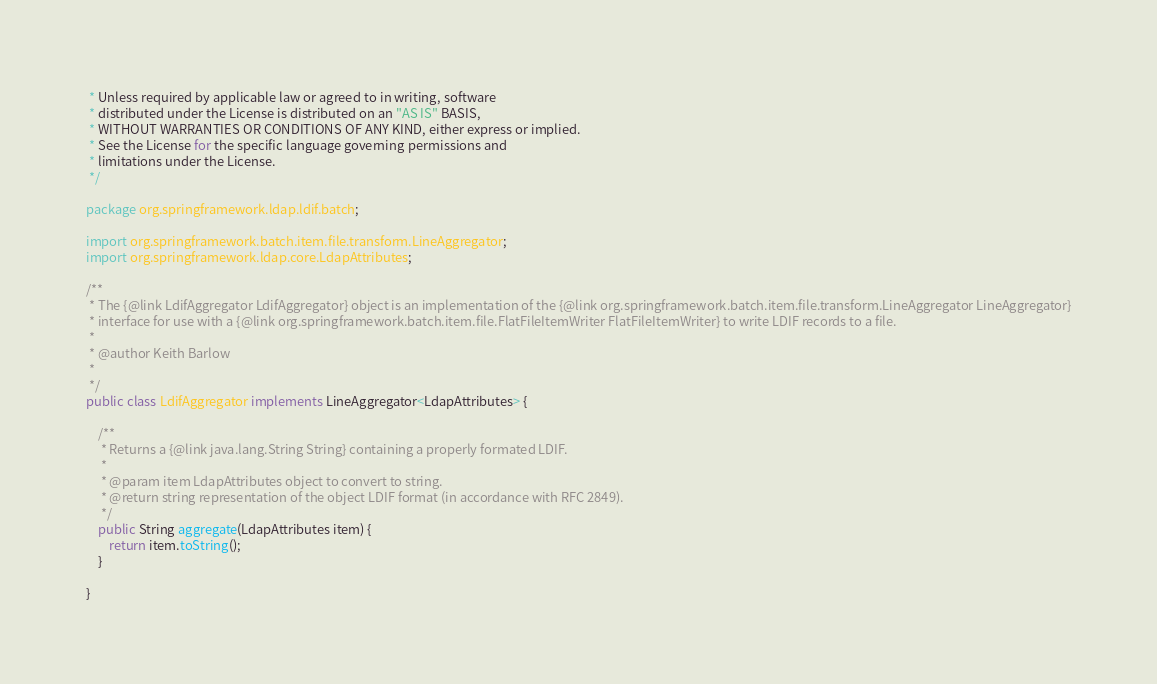Convert code to text. <code><loc_0><loc_0><loc_500><loc_500><_Java_> * Unless required by applicable law or agreed to in writing, software
 * distributed under the License is distributed on an "AS IS" BASIS,
 * WITHOUT WARRANTIES OR CONDITIONS OF ANY KIND, either express or implied.
 * See the License for the specific language governing permissions and
 * limitations under the License.
 */

package org.springframework.ldap.ldif.batch;

import org.springframework.batch.item.file.transform.LineAggregator;
import org.springframework.ldap.core.LdapAttributes;

/**
 * The {@link LdifAggregator LdifAggregator} object is an implementation of the {@link org.springframework.batch.item.file.transform.LineAggregator LineAggregator}
 * interface for use with a {@link org.springframework.batch.item.file.FlatFileItemWriter FlatFileItemWriter} to write LDIF records to a file.
 * 
 * @author Keith Barlow
 *
 */
public class LdifAggregator implements LineAggregator<LdapAttributes> {

	/**
	 * Returns a {@link java.lang.String String} containing a properly formated LDIF.
	 * 
	 * @param item LdapAttributes object to convert to string.
	 * @return string representation of the object LDIF format (in accordance with RFC 2849).
	 */
	public String aggregate(LdapAttributes item) {
		return item.toString();
	}

}
</code> 